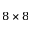Convert formula to latex. <formula><loc_0><loc_0><loc_500><loc_500>8 \times 8</formula> 